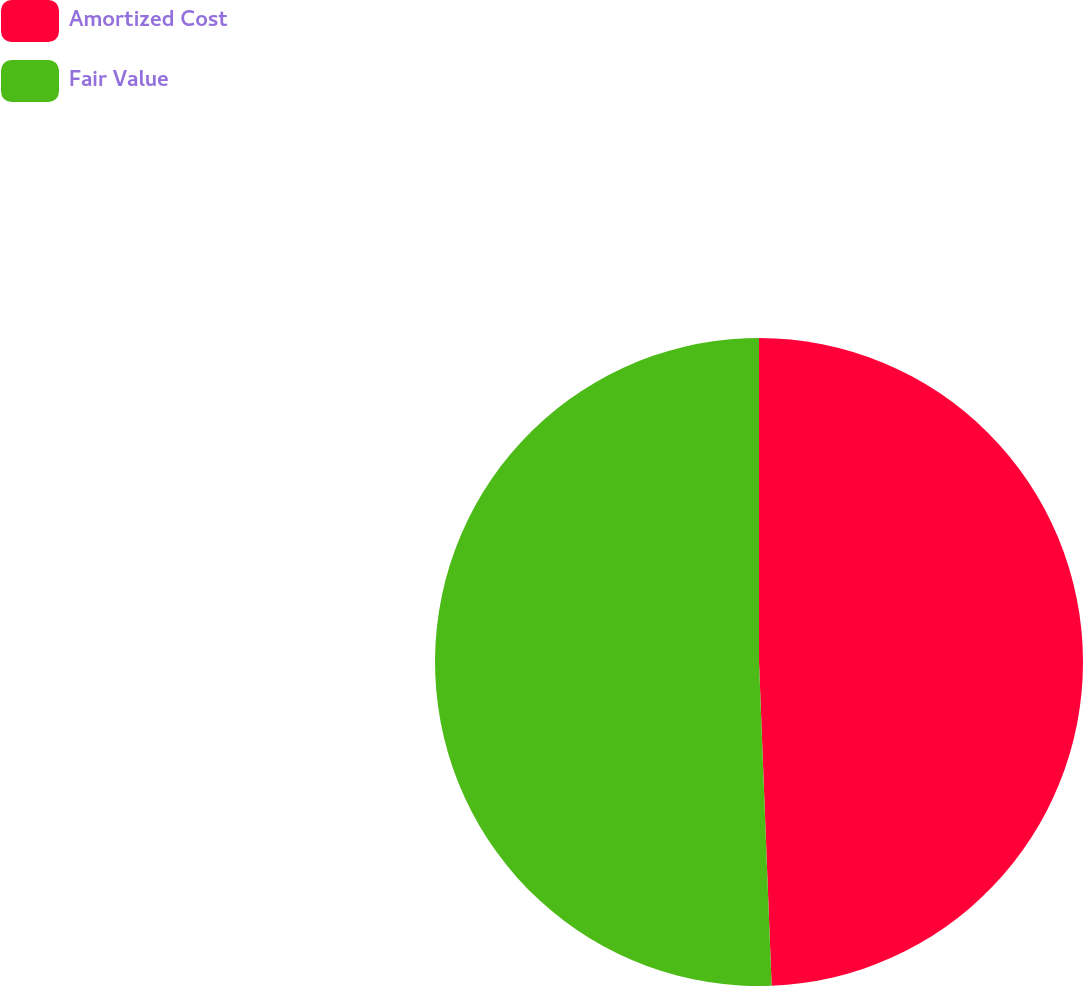<chart> <loc_0><loc_0><loc_500><loc_500><pie_chart><fcel>Amortized Cost<fcel>Fair Value<nl><fcel>49.38%<fcel>50.62%<nl></chart> 